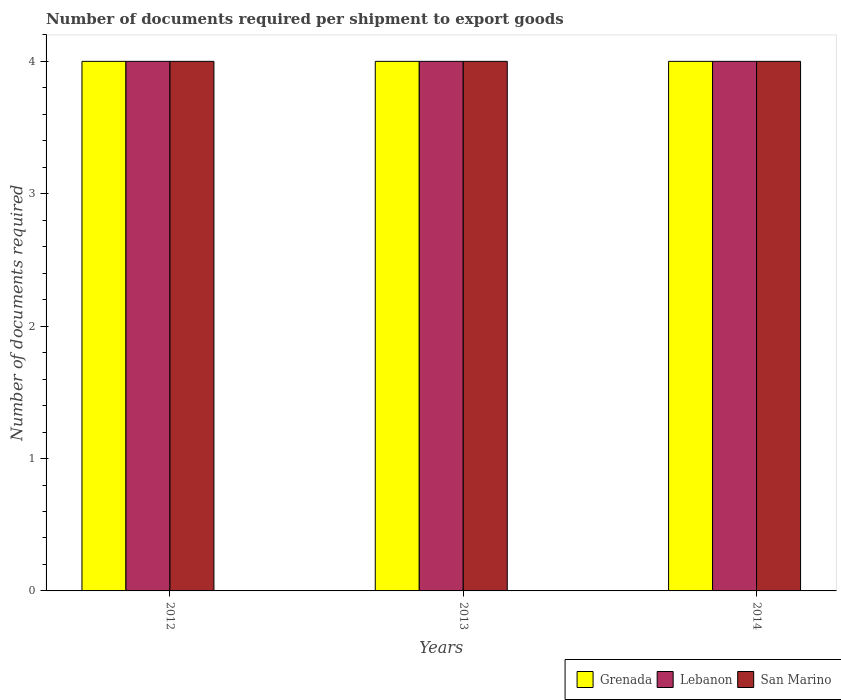How many groups of bars are there?
Offer a very short reply. 3. What is the number of documents required per shipment to export goods in Lebanon in 2013?
Make the answer very short. 4. Across all years, what is the maximum number of documents required per shipment to export goods in Grenada?
Keep it short and to the point. 4. In which year was the number of documents required per shipment to export goods in Lebanon minimum?
Ensure brevity in your answer.  2012. What is the total number of documents required per shipment to export goods in Lebanon in the graph?
Provide a succinct answer. 12. What is the difference between the number of documents required per shipment to export goods in Grenada in 2012 and the number of documents required per shipment to export goods in San Marino in 2013?
Provide a short and direct response. 0. What is the average number of documents required per shipment to export goods in Grenada per year?
Provide a succinct answer. 4. What is the ratio of the number of documents required per shipment to export goods in Grenada in 2012 to that in 2014?
Offer a terse response. 1. Is the number of documents required per shipment to export goods in Grenada in 2013 less than that in 2014?
Offer a very short reply. No. Is the sum of the number of documents required per shipment to export goods in Grenada in 2012 and 2013 greater than the maximum number of documents required per shipment to export goods in San Marino across all years?
Provide a short and direct response. Yes. What does the 2nd bar from the left in 2014 represents?
Ensure brevity in your answer.  Lebanon. What does the 1st bar from the right in 2012 represents?
Make the answer very short. San Marino. Is it the case that in every year, the sum of the number of documents required per shipment to export goods in Grenada and number of documents required per shipment to export goods in San Marino is greater than the number of documents required per shipment to export goods in Lebanon?
Make the answer very short. Yes. How many bars are there?
Offer a terse response. 9. How many years are there in the graph?
Provide a succinct answer. 3. What is the difference between two consecutive major ticks on the Y-axis?
Your answer should be very brief. 1. Are the values on the major ticks of Y-axis written in scientific E-notation?
Your answer should be very brief. No. Does the graph contain any zero values?
Offer a terse response. No. Does the graph contain grids?
Your response must be concise. No. Where does the legend appear in the graph?
Ensure brevity in your answer.  Bottom right. How are the legend labels stacked?
Offer a terse response. Horizontal. What is the title of the graph?
Offer a terse response. Number of documents required per shipment to export goods. What is the label or title of the X-axis?
Your answer should be compact. Years. What is the label or title of the Y-axis?
Offer a terse response. Number of documents required. What is the Number of documents required of Lebanon in 2013?
Offer a terse response. 4. What is the Number of documents required of Lebanon in 2014?
Keep it short and to the point. 4. Across all years, what is the maximum Number of documents required in Grenada?
Your answer should be compact. 4. Across all years, what is the minimum Number of documents required of Lebanon?
Ensure brevity in your answer.  4. Across all years, what is the minimum Number of documents required in San Marino?
Your answer should be compact. 4. What is the total Number of documents required in Lebanon in the graph?
Provide a succinct answer. 12. What is the total Number of documents required of San Marino in the graph?
Your response must be concise. 12. What is the difference between the Number of documents required in Lebanon in 2012 and that in 2013?
Your answer should be very brief. 0. What is the difference between the Number of documents required of Lebanon in 2012 and that in 2014?
Your response must be concise. 0. What is the difference between the Number of documents required in San Marino in 2013 and that in 2014?
Give a very brief answer. 0. What is the difference between the Number of documents required of Lebanon in 2012 and the Number of documents required of San Marino in 2013?
Your answer should be very brief. 0. What is the difference between the Number of documents required in Grenada in 2012 and the Number of documents required in Lebanon in 2014?
Your answer should be compact. 0. What is the difference between the Number of documents required in Lebanon in 2013 and the Number of documents required in San Marino in 2014?
Keep it short and to the point. 0. What is the average Number of documents required of Lebanon per year?
Ensure brevity in your answer.  4. In the year 2012, what is the difference between the Number of documents required of Grenada and Number of documents required of Lebanon?
Provide a succinct answer. 0. In the year 2012, what is the difference between the Number of documents required in Grenada and Number of documents required in San Marino?
Provide a succinct answer. 0. In the year 2012, what is the difference between the Number of documents required of Lebanon and Number of documents required of San Marino?
Give a very brief answer. 0. In the year 2013, what is the difference between the Number of documents required of Grenada and Number of documents required of San Marino?
Give a very brief answer. 0. In the year 2014, what is the difference between the Number of documents required of Grenada and Number of documents required of Lebanon?
Your response must be concise. 0. What is the ratio of the Number of documents required of San Marino in 2012 to that in 2013?
Make the answer very short. 1. What is the ratio of the Number of documents required in Lebanon in 2012 to that in 2014?
Provide a succinct answer. 1. What is the ratio of the Number of documents required in San Marino in 2012 to that in 2014?
Provide a succinct answer. 1. What is the ratio of the Number of documents required in Lebanon in 2013 to that in 2014?
Your answer should be very brief. 1. What is the difference between the highest and the second highest Number of documents required in Lebanon?
Keep it short and to the point. 0. 